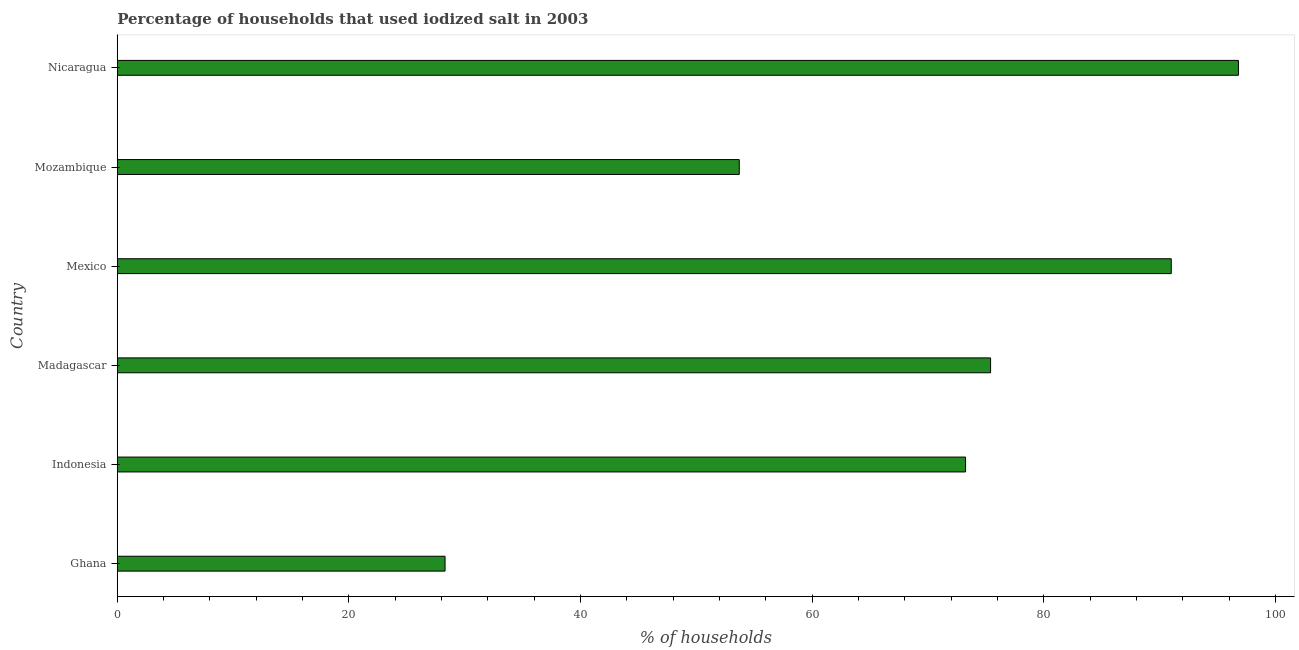Does the graph contain any zero values?
Offer a very short reply. No. What is the title of the graph?
Keep it short and to the point. Percentage of households that used iodized salt in 2003. What is the label or title of the X-axis?
Your response must be concise. % of households. What is the percentage of households where iodized salt is consumed in Mozambique?
Make the answer very short. 53.7. Across all countries, what is the maximum percentage of households where iodized salt is consumed?
Ensure brevity in your answer.  96.8. Across all countries, what is the minimum percentage of households where iodized salt is consumed?
Your answer should be very brief. 28.3. In which country was the percentage of households where iodized salt is consumed maximum?
Provide a succinct answer. Nicaragua. What is the sum of the percentage of households where iodized salt is consumed?
Your response must be concise. 418.44. What is the average percentage of households where iodized salt is consumed per country?
Give a very brief answer. 69.74. What is the median percentage of households where iodized salt is consumed?
Offer a terse response. 74.32. What is the ratio of the percentage of households where iodized salt is consumed in Indonesia to that in Nicaragua?
Make the answer very short. 0.76. What is the difference between the highest and the second highest percentage of households where iodized salt is consumed?
Make the answer very short. 5.8. Is the sum of the percentage of households where iodized salt is consumed in Madagascar and Mexico greater than the maximum percentage of households where iodized salt is consumed across all countries?
Provide a short and direct response. Yes. What is the difference between the highest and the lowest percentage of households where iodized salt is consumed?
Provide a succinct answer. 68.5. In how many countries, is the percentage of households where iodized salt is consumed greater than the average percentage of households where iodized salt is consumed taken over all countries?
Provide a succinct answer. 4. What is the difference between two consecutive major ticks on the X-axis?
Offer a terse response. 20. Are the values on the major ticks of X-axis written in scientific E-notation?
Your answer should be compact. No. What is the % of households of Ghana?
Give a very brief answer. 28.3. What is the % of households in Indonesia?
Provide a succinct answer. 73.24. What is the % of households of Madagascar?
Provide a succinct answer. 75.4. What is the % of households in Mexico?
Provide a short and direct response. 91. What is the % of households of Mozambique?
Your answer should be very brief. 53.7. What is the % of households in Nicaragua?
Ensure brevity in your answer.  96.8. What is the difference between the % of households in Ghana and Indonesia?
Ensure brevity in your answer.  -44.94. What is the difference between the % of households in Ghana and Madagascar?
Keep it short and to the point. -47.1. What is the difference between the % of households in Ghana and Mexico?
Make the answer very short. -62.7. What is the difference between the % of households in Ghana and Mozambique?
Your response must be concise. -25.4. What is the difference between the % of households in Ghana and Nicaragua?
Offer a very short reply. -68.5. What is the difference between the % of households in Indonesia and Madagascar?
Provide a succinct answer. -2.16. What is the difference between the % of households in Indonesia and Mexico?
Offer a terse response. -17.76. What is the difference between the % of households in Indonesia and Mozambique?
Provide a short and direct response. 19.54. What is the difference between the % of households in Indonesia and Nicaragua?
Give a very brief answer. -23.56. What is the difference between the % of households in Madagascar and Mexico?
Your response must be concise. -15.6. What is the difference between the % of households in Madagascar and Mozambique?
Ensure brevity in your answer.  21.7. What is the difference between the % of households in Madagascar and Nicaragua?
Your answer should be very brief. -21.4. What is the difference between the % of households in Mexico and Mozambique?
Your answer should be compact. 37.3. What is the difference between the % of households in Mozambique and Nicaragua?
Give a very brief answer. -43.1. What is the ratio of the % of households in Ghana to that in Indonesia?
Provide a short and direct response. 0.39. What is the ratio of the % of households in Ghana to that in Mexico?
Ensure brevity in your answer.  0.31. What is the ratio of the % of households in Ghana to that in Mozambique?
Ensure brevity in your answer.  0.53. What is the ratio of the % of households in Ghana to that in Nicaragua?
Offer a terse response. 0.29. What is the ratio of the % of households in Indonesia to that in Mexico?
Offer a very short reply. 0.81. What is the ratio of the % of households in Indonesia to that in Mozambique?
Keep it short and to the point. 1.36. What is the ratio of the % of households in Indonesia to that in Nicaragua?
Give a very brief answer. 0.76. What is the ratio of the % of households in Madagascar to that in Mexico?
Provide a succinct answer. 0.83. What is the ratio of the % of households in Madagascar to that in Mozambique?
Your answer should be very brief. 1.4. What is the ratio of the % of households in Madagascar to that in Nicaragua?
Make the answer very short. 0.78. What is the ratio of the % of households in Mexico to that in Mozambique?
Provide a short and direct response. 1.7. What is the ratio of the % of households in Mexico to that in Nicaragua?
Ensure brevity in your answer.  0.94. What is the ratio of the % of households in Mozambique to that in Nicaragua?
Keep it short and to the point. 0.56. 